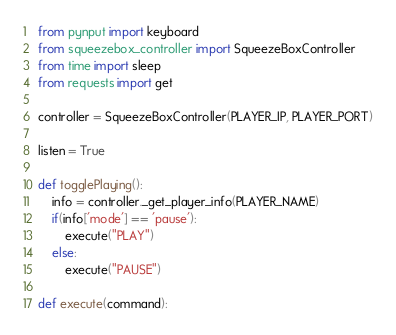<code> <loc_0><loc_0><loc_500><loc_500><_Python_>from pynput import keyboard
from squeezebox_controller import SqueezeBoxController
from time import sleep
from requests import get

controller = SqueezeBoxController(PLAYER_IP, PLAYER_PORT)

listen = True

def togglePlaying():
    info = controller._get_player_info(PLAYER_NAME)
    if(info['mode'] == 'pause'):
        execute("PLAY")
    else:
        execute("PAUSE")

def execute(command):</code> 